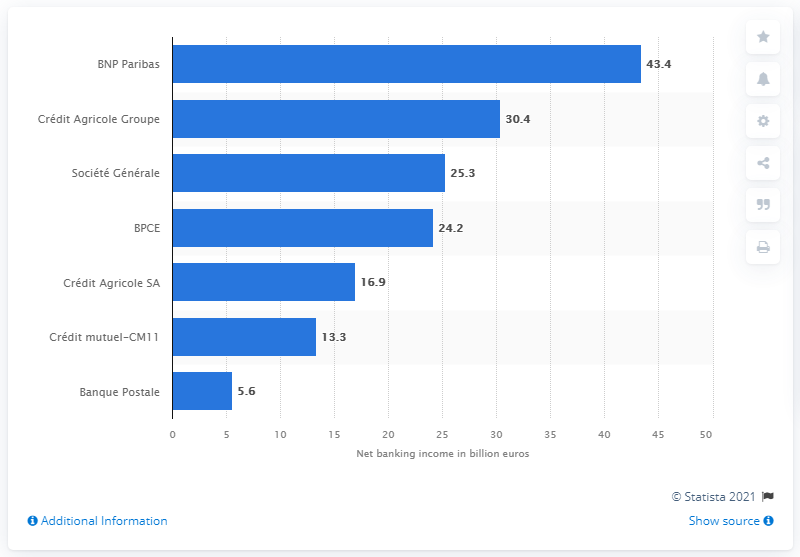What was the value of BNP Paribas's net income in 2016? In 2016, BNP Paribas reported a net banking income of 43.4 billion euros, as indicated in the bar chart from the displayed data. 